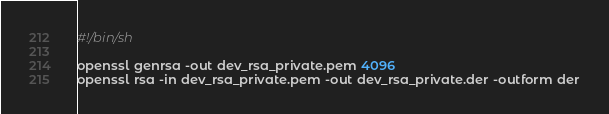<code> <loc_0><loc_0><loc_500><loc_500><_Bash_>#!/bin/sh

openssl genrsa -out dev_rsa_private.pem 4096
openssl rsa -in dev_rsa_private.pem -out dev_rsa_private.der -outform der</code> 